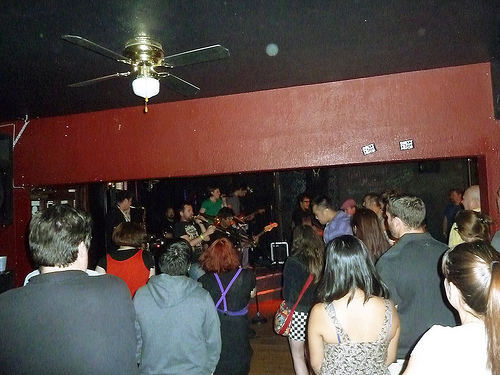<image>
Is there a man behind the woman? Yes. From this viewpoint, the man is positioned behind the woman, with the woman partially or fully occluding the man. 